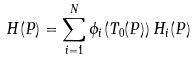Convert formula to latex. <formula><loc_0><loc_0><loc_500><loc_500>H ( P ) = \sum _ { i = 1 } ^ { N } \phi _ { i } ( T _ { 0 } ( P ) ) \, H _ { i } ( P )</formula> 